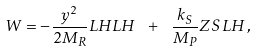<formula> <loc_0><loc_0><loc_500><loc_500>W = - \frac { y ^ { 2 } } { 2 M _ { R } } L H L H \ + \ \frac { k _ { S } } { M _ { P } } Z S L H \, ,</formula> 